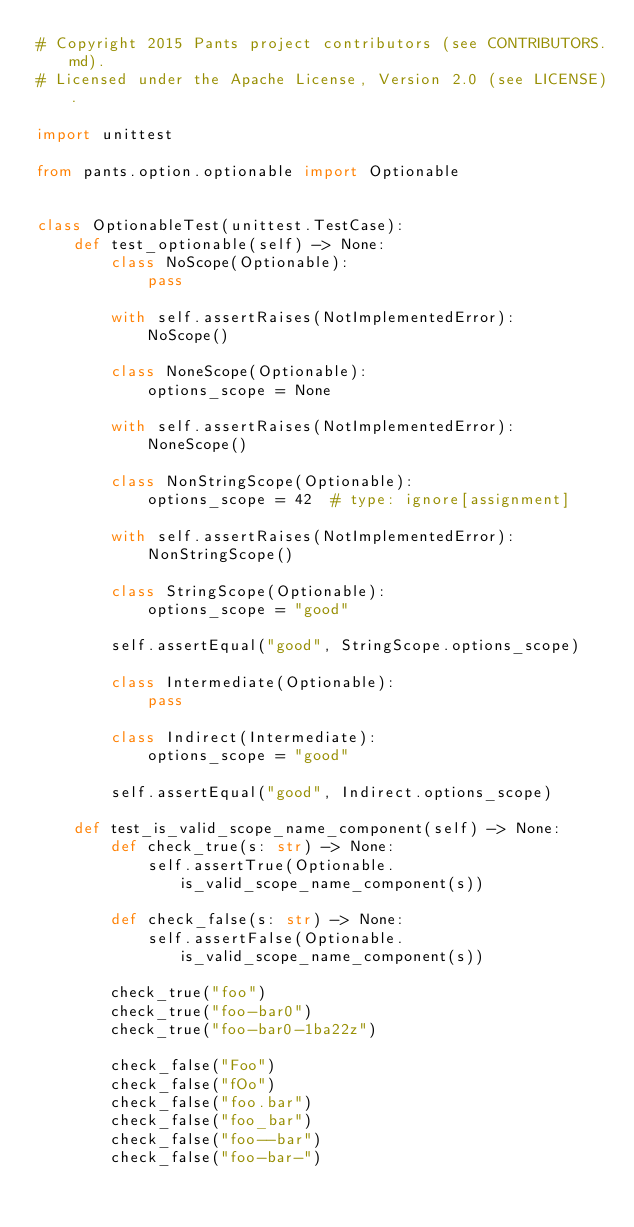Convert code to text. <code><loc_0><loc_0><loc_500><loc_500><_Python_># Copyright 2015 Pants project contributors (see CONTRIBUTORS.md).
# Licensed under the Apache License, Version 2.0 (see LICENSE).

import unittest

from pants.option.optionable import Optionable


class OptionableTest(unittest.TestCase):
    def test_optionable(self) -> None:
        class NoScope(Optionable):
            pass

        with self.assertRaises(NotImplementedError):
            NoScope()

        class NoneScope(Optionable):
            options_scope = None

        with self.assertRaises(NotImplementedError):
            NoneScope()

        class NonStringScope(Optionable):
            options_scope = 42  # type: ignore[assignment]

        with self.assertRaises(NotImplementedError):
            NonStringScope()

        class StringScope(Optionable):
            options_scope = "good"

        self.assertEqual("good", StringScope.options_scope)

        class Intermediate(Optionable):
            pass

        class Indirect(Intermediate):
            options_scope = "good"

        self.assertEqual("good", Indirect.options_scope)

    def test_is_valid_scope_name_component(self) -> None:
        def check_true(s: str) -> None:
            self.assertTrue(Optionable.is_valid_scope_name_component(s))

        def check_false(s: str) -> None:
            self.assertFalse(Optionable.is_valid_scope_name_component(s))

        check_true("foo")
        check_true("foo-bar0")
        check_true("foo-bar0-1ba22z")

        check_false("Foo")
        check_false("fOo")
        check_false("foo.bar")
        check_false("foo_bar")
        check_false("foo--bar")
        check_false("foo-bar-")
</code> 